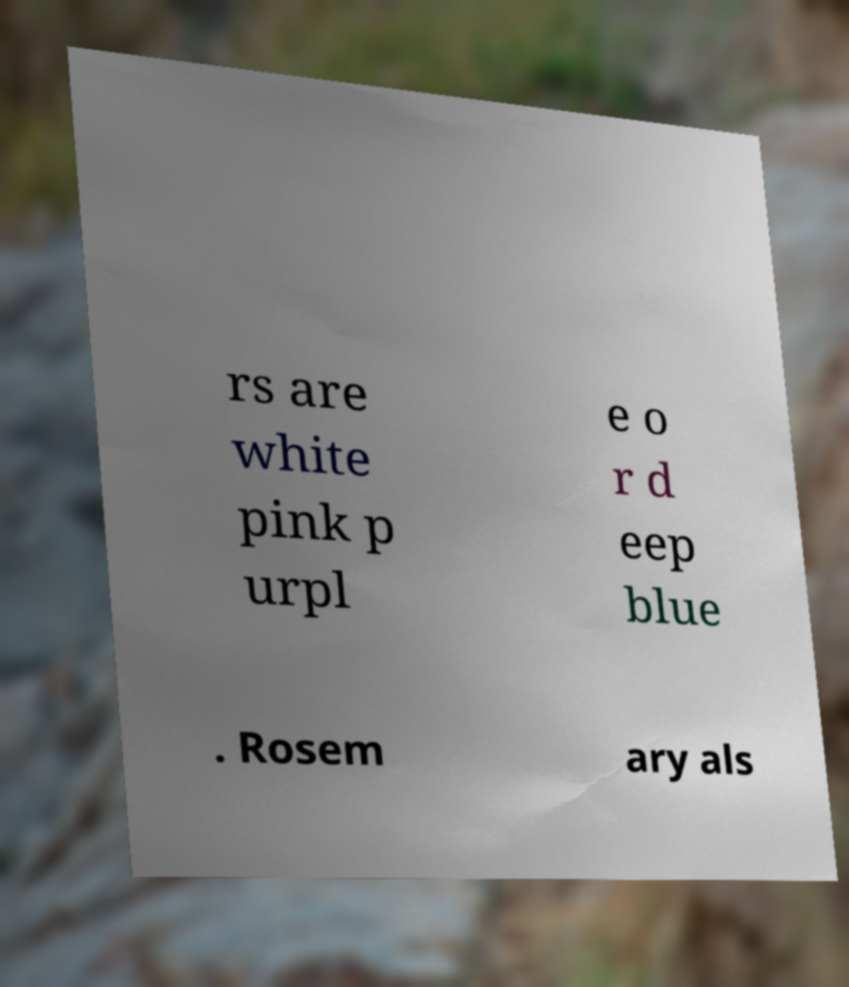Can you read and provide the text displayed in the image?This photo seems to have some interesting text. Can you extract and type it out for me? rs are white pink p urpl e o r d eep blue . Rosem ary als 